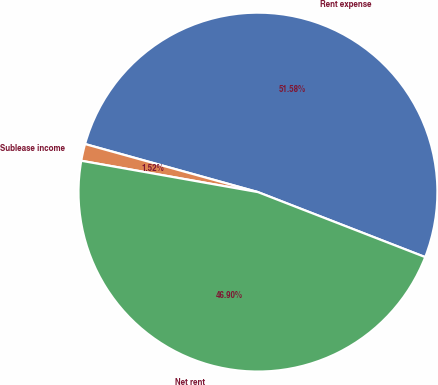<chart> <loc_0><loc_0><loc_500><loc_500><pie_chart><fcel>Rent expense<fcel>Sublease income<fcel>Net rent<nl><fcel>51.59%<fcel>1.52%<fcel>46.9%<nl></chart> 